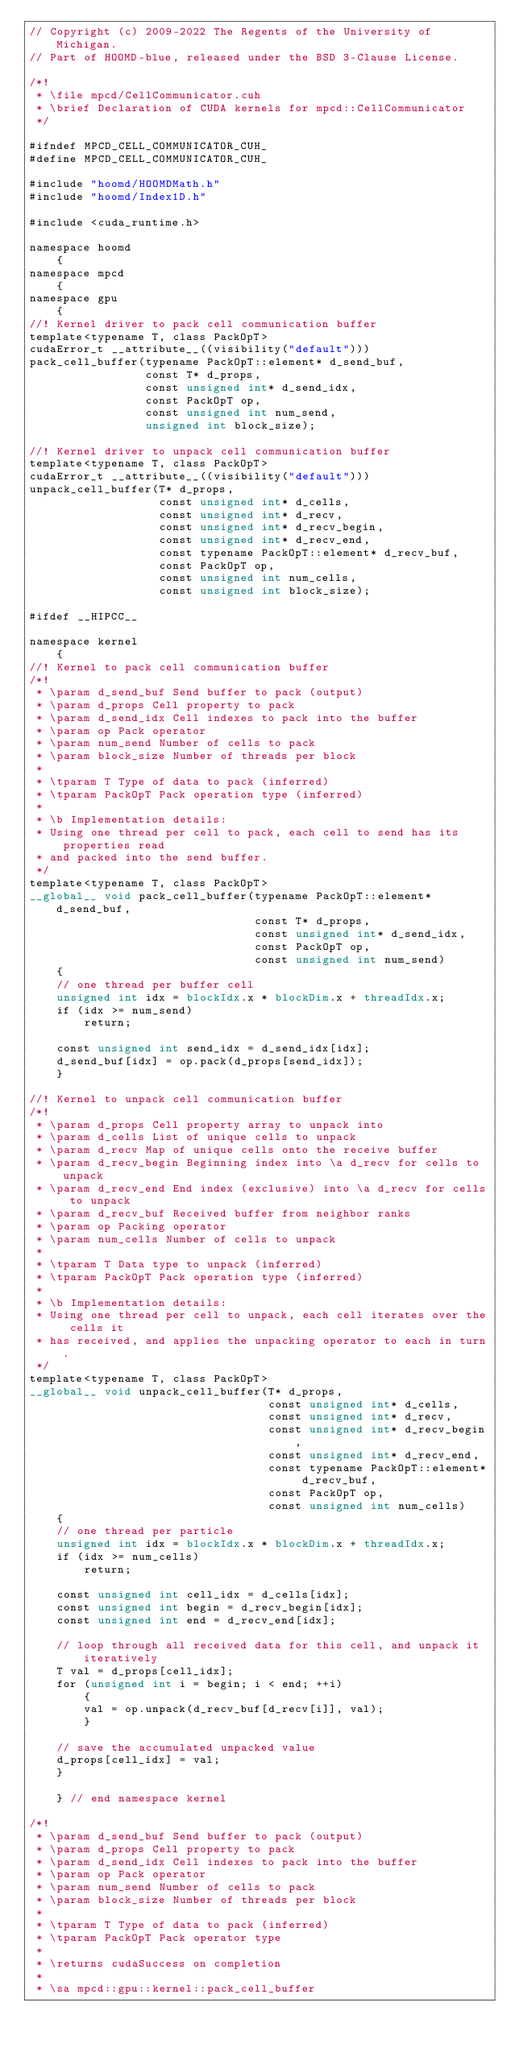<code> <loc_0><loc_0><loc_500><loc_500><_Cuda_>// Copyright (c) 2009-2022 The Regents of the University of Michigan.
// Part of HOOMD-blue, released under the BSD 3-Clause License.

/*!
 * \file mpcd/CellCommunicator.cuh
 * \brief Declaration of CUDA kernels for mpcd::CellCommunicator
 */

#ifndef MPCD_CELL_COMMUNICATOR_CUH_
#define MPCD_CELL_COMMUNICATOR_CUH_

#include "hoomd/HOOMDMath.h"
#include "hoomd/Index1D.h"

#include <cuda_runtime.h>

namespace hoomd
    {
namespace mpcd
    {
namespace gpu
    {
//! Kernel driver to pack cell communication buffer
template<typename T, class PackOpT>
cudaError_t __attribute__((visibility("default")))
pack_cell_buffer(typename PackOpT::element* d_send_buf,
                 const T* d_props,
                 const unsigned int* d_send_idx,
                 const PackOpT op,
                 const unsigned int num_send,
                 unsigned int block_size);

//! Kernel driver to unpack cell communication buffer
template<typename T, class PackOpT>
cudaError_t __attribute__((visibility("default")))
unpack_cell_buffer(T* d_props,
                   const unsigned int* d_cells,
                   const unsigned int* d_recv,
                   const unsigned int* d_recv_begin,
                   const unsigned int* d_recv_end,
                   const typename PackOpT::element* d_recv_buf,
                   const PackOpT op,
                   const unsigned int num_cells,
                   const unsigned int block_size);

#ifdef __HIPCC__

namespace kernel
    {
//! Kernel to pack cell communication buffer
/*!
 * \param d_send_buf Send buffer to pack (output)
 * \param d_props Cell property to pack
 * \param d_send_idx Cell indexes to pack into the buffer
 * \param op Pack operator
 * \param num_send Number of cells to pack
 * \param block_size Number of threads per block
 *
 * \tparam T Type of data to pack (inferred)
 * \tparam PackOpT Pack operation type (inferred)
 *
 * \b Implementation details:
 * Using one thread per cell to pack, each cell to send has its properties read
 * and packed into the send buffer.
 */
template<typename T, class PackOpT>
__global__ void pack_cell_buffer(typename PackOpT::element* d_send_buf,
                                 const T* d_props,
                                 const unsigned int* d_send_idx,
                                 const PackOpT op,
                                 const unsigned int num_send)
    {
    // one thread per buffer cell
    unsigned int idx = blockIdx.x * blockDim.x + threadIdx.x;
    if (idx >= num_send)
        return;

    const unsigned int send_idx = d_send_idx[idx];
    d_send_buf[idx] = op.pack(d_props[send_idx]);
    }

//! Kernel to unpack cell communication buffer
/*!
 * \param d_props Cell property array to unpack into
 * \param d_cells List of unique cells to unpack
 * \param d_recv Map of unique cells onto the receive buffer
 * \param d_recv_begin Beginning index into \a d_recv for cells to unpack
 * \param d_recv_end End index (exclusive) into \a d_recv for cells to unpack
 * \param d_recv_buf Received buffer from neighbor ranks
 * \param op Packing operator
 * \param num_cells Number of cells to unpack
 *
 * \tparam T Data type to unpack (inferred)
 * \tparam PackOpT Pack operation type (inferred)
 *
 * \b Implementation details:
 * Using one thread per cell to unpack, each cell iterates over the cells it
 * has received, and applies the unpacking operator to each in turn.
 */
template<typename T, class PackOpT>
__global__ void unpack_cell_buffer(T* d_props,
                                   const unsigned int* d_cells,
                                   const unsigned int* d_recv,
                                   const unsigned int* d_recv_begin,
                                   const unsigned int* d_recv_end,
                                   const typename PackOpT::element* d_recv_buf,
                                   const PackOpT op,
                                   const unsigned int num_cells)
    {
    // one thread per particle
    unsigned int idx = blockIdx.x * blockDim.x + threadIdx.x;
    if (idx >= num_cells)
        return;

    const unsigned int cell_idx = d_cells[idx];
    const unsigned int begin = d_recv_begin[idx];
    const unsigned int end = d_recv_end[idx];

    // loop through all received data for this cell, and unpack it iteratively
    T val = d_props[cell_idx];
    for (unsigned int i = begin; i < end; ++i)
        {
        val = op.unpack(d_recv_buf[d_recv[i]], val);
        }

    // save the accumulated unpacked value
    d_props[cell_idx] = val;
    }

    } // end namespace kernel

/*!
 * \param d_send_buf Send buffer to pack (output)
 * \param d_props Cell property to pack
 * \param d_send_idx Cell indexes to pack into the buffer
 * \param op Pack operator
 * \param num_send Number of cells to pack
 * \param block_size Number of threads per block
 *
 * \tparam T Type of data to pack (inferred)
 * \tparam PackOpT Pack operator type
 *
 * \returns cudaSuccess on completion
 *
 * \sa mpcd::gpu::kernel::pack_cell_buffer</code> 